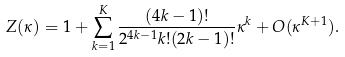<formula> <loc_0><loc_0><loc_500><loc_500>Z ( \kappa ) = 1 + \sum _ { k = 1 } ^ { K } \frac { ( 4 k - 1 ) ! } { 2 ^ { 4 k - 1 } k ! ( 2 k - 1 ) ! } \kappa ^ { k } + O ( \kappa ^ { K + 1 } ) .</formula> 